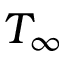<formula> <loc_0><loc_0><loc_500><loc_500>T _ { \infty }</formula> 